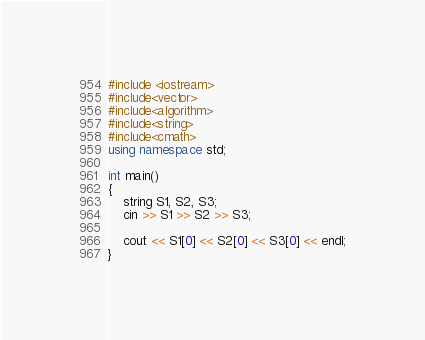Convert code to text. <code><loc_0><loc_0><loc_500><loc_500><_C++_>#include <iostream>
#include<vector>
#include<algorithm>
#include<string>
#include<cmath>
using namespace std;

int main()
{
	string S1, S2, S3;
	cin >> S1 >> S2 >> S3;

	cout << S1[0] << S2[0] << S3[0] << endl;
}




</code> 